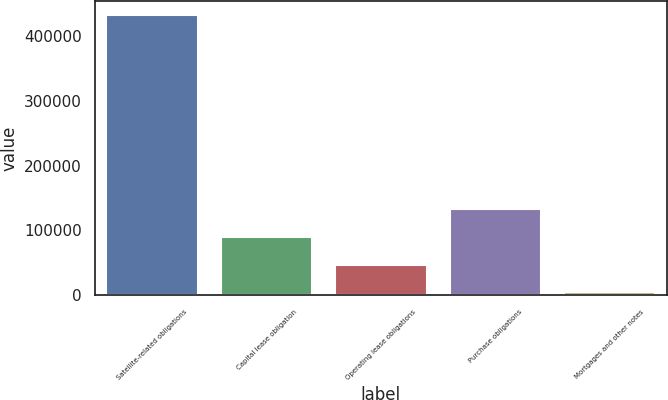Convert chart to OTSL. <chart><loc_0><loc_0><loc_500><loc_500><bar_chart><fcel>Satellite-related obligations<fcel>Capital lease obligation<fcel>Operating lease obligations<fcel>Purchase obligations<fcel>Mortgages and other notes<nl><fcel>432335<fcel>89950.2<fcel>47152.1<fcel>132748<fcel>4354<nl></chart> 